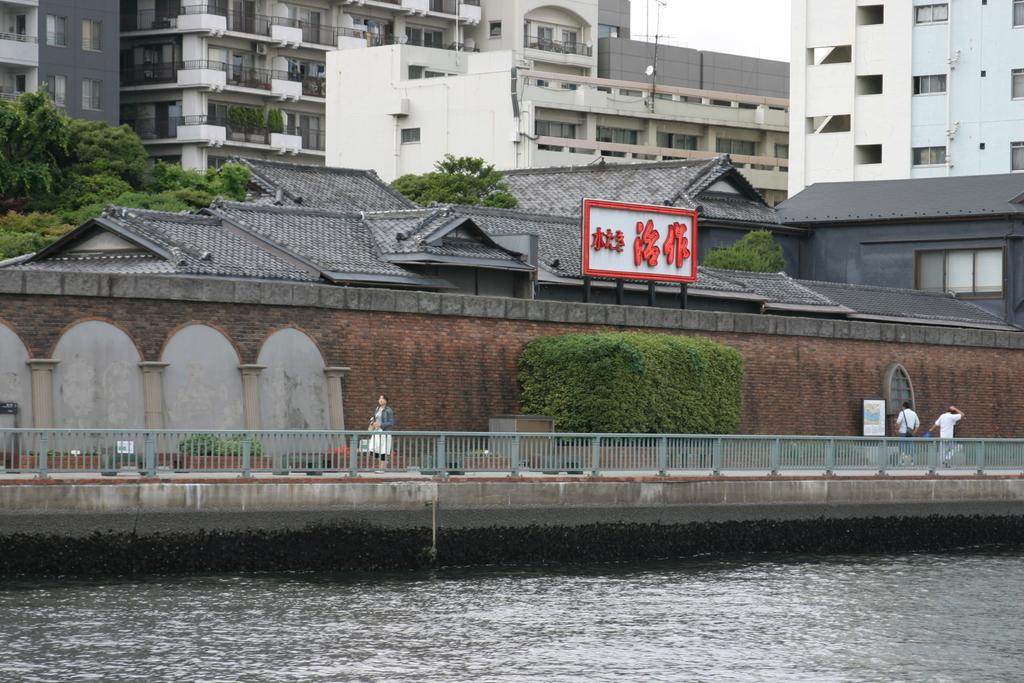What is the main feature of the image? There is water in the image. What can be seen near the water? There is a walkway in the image, and people are walking on it. What is visible in the background of the image? There are houses, buildings, and trees in the background of the image. Where is the turkey located in the image? There is no turkey present in the image. What type of tub can be seen in the image? There is no tub present in the image. 